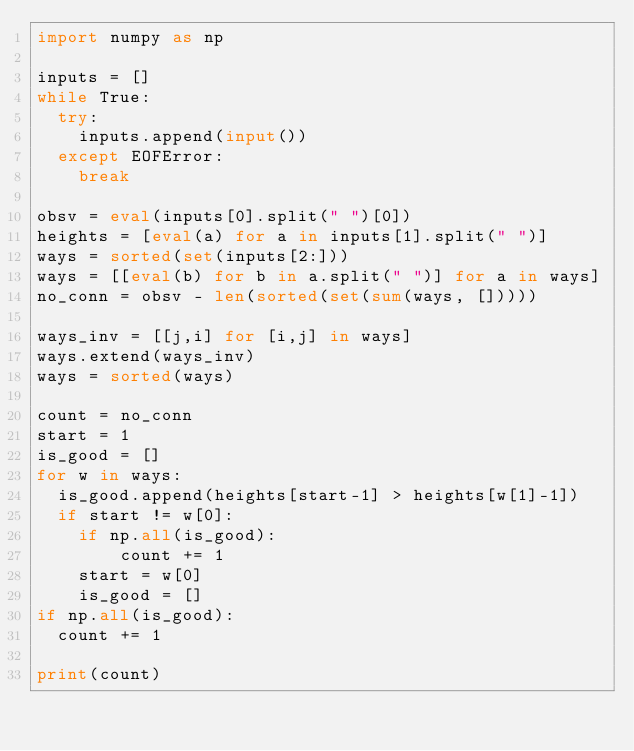<code> <loc_0><loc_0><loc_500><loc_500><_Python_>import numpy as np

inputs = []
while True:
  try:
    inputs.append(input())
  except EOFError:
    break

obsv = eval(inputs[0].split(" ")[0])
heights = [eval(a) for a in inputs[1].split(" ")]
ways = sorted(set(inputs[2:]))
ways = [[eval(b) for b in a.split(" ")] for a in ways]
no_conn = obsv - len(sorted(set(sum(ways, []))))

ways_inv = [[j,i] for [i,j] in ways]
ways.extend(ways_inv)
ways = sorted(ways)

count = no_conn
start = 1
is_good = []
for w in ways:
  is_good.append(heights[start-1] > heights[w[1]-1])
  if start != w[0]:
    if np.all(is_good):
        count += 1
    start = w[0]
    is_good = []
if np.all(is_good):
  count += 1
  
print(count)</code> 